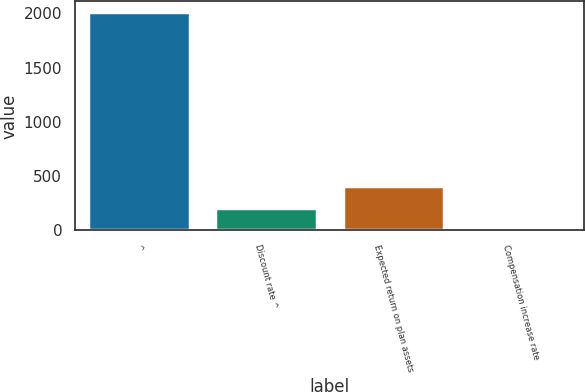Convert chart. <chart><loc_0><loc_0><loc_500><loc_500><bar_chart><fcel>^<fcel>Discount rate ^<fcel>Expected return on plan assets<fcel>Compensation increase rate<nl><fcel>2009<fcel>204.73<fcel>405.21<fcel>4.25<nl></chart> 